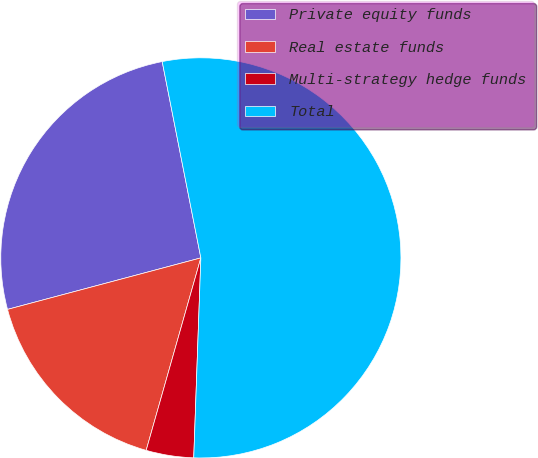<chart> <loc_0><loc_0><loc_500><loc_500><pie_chart><fcel>Private equity funds<fcel>Real estate funds<fcel>Multi-strategy hedge funds<fcel>Total<nl><fcel>26.05%<fcel>16.45%<fcel>3.84%<fcel>53.66%<nl></chart> 